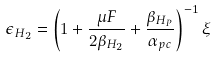Convert formula to latex. <formula><loc_0><loc_0><loc_500><loc_500>\epsilon _ { H _ { 2 } } = \left ( { { 1 + { \frac { \mu F } { 2 \beta _ { H _ { 2 } } } } + { \frac { \beta _ { H _ { P } } } { \alpha _ { p c } } } } } \right ) ^ { - 1 } \xi \\</formula> 